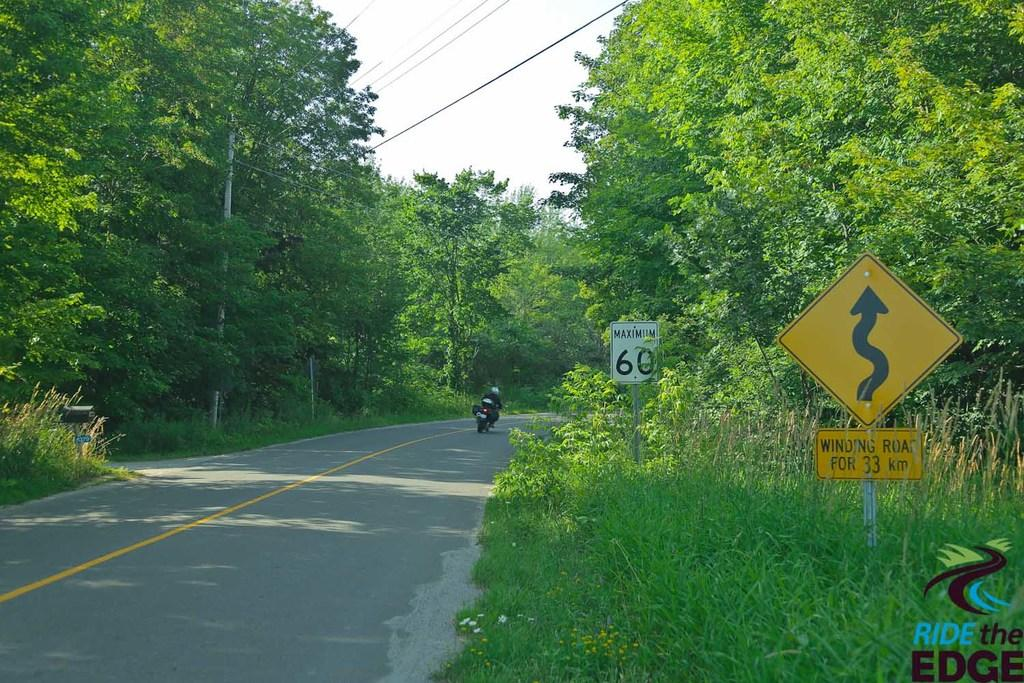<image>
Provide a brief description of the given image. The maximum speed on this road is 60. 